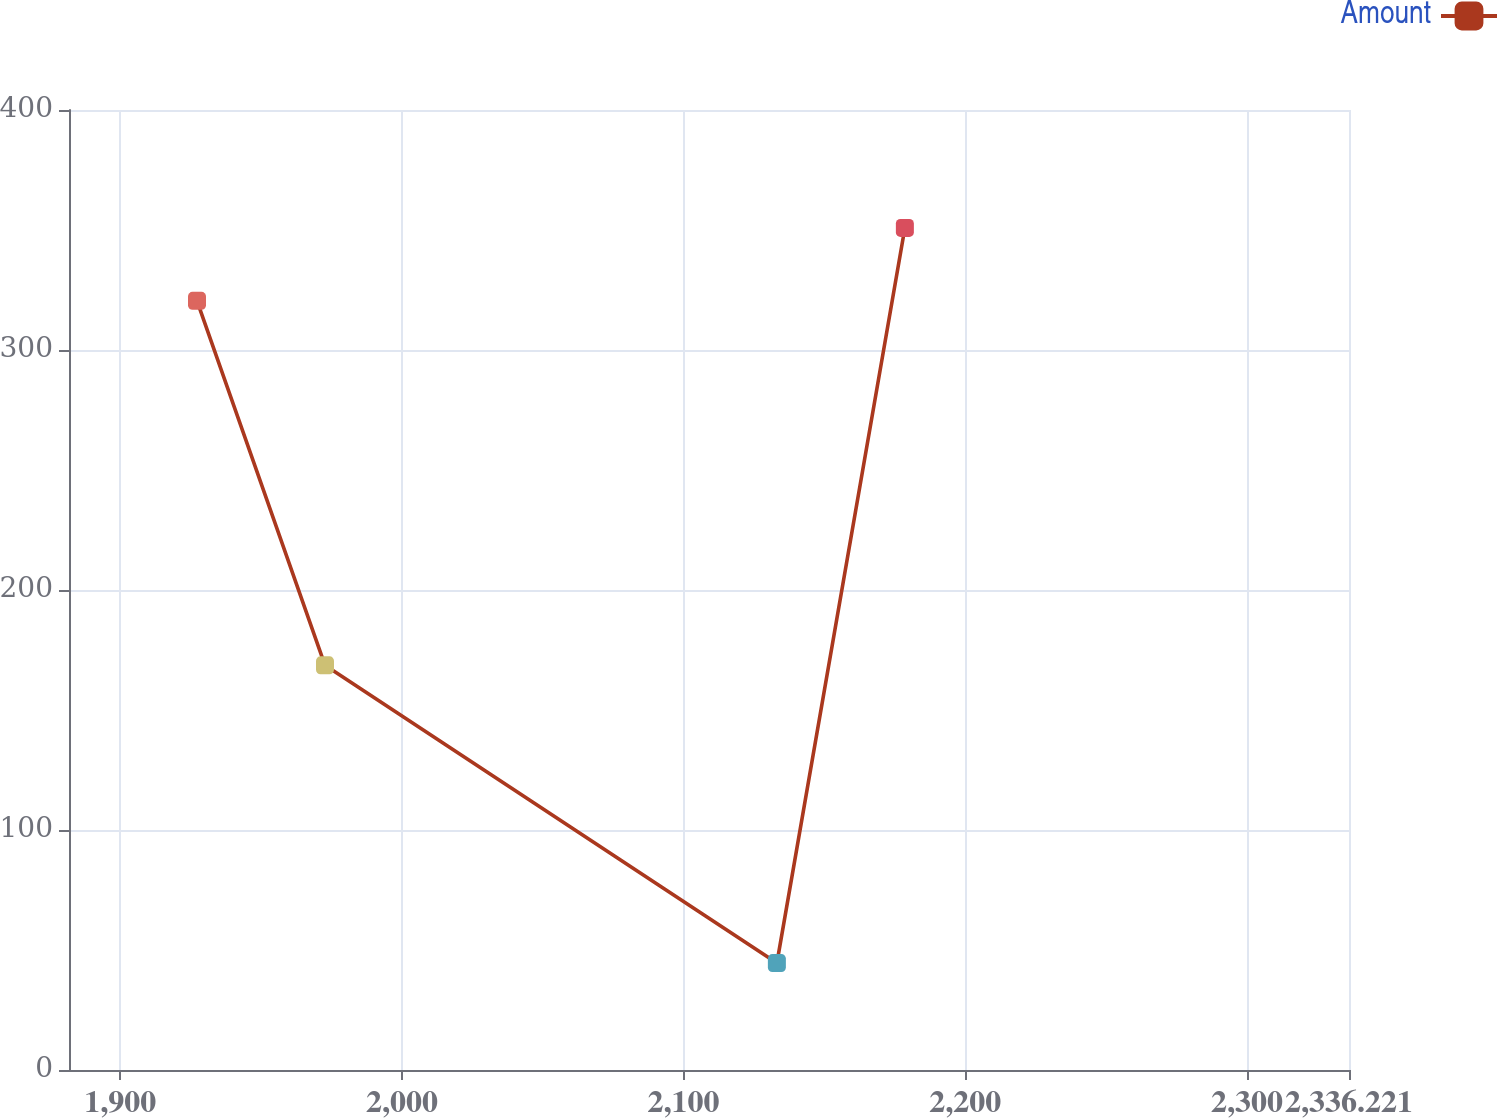Convert chart to OTSL. <chart><loc_0><loc_0><loc_500><loc_500><line_chart><ecel><fcel>Amount<nl><fcel>1927.27<fcel>320.48<nl><fcel>1972.71<fcel>168.6<nl><fcel>2133.12<fcel>44.54<nl><fcel>2178.56<fcel>350.86<nl><fcel>2381.66<fcel>138.22<nl></chart> 